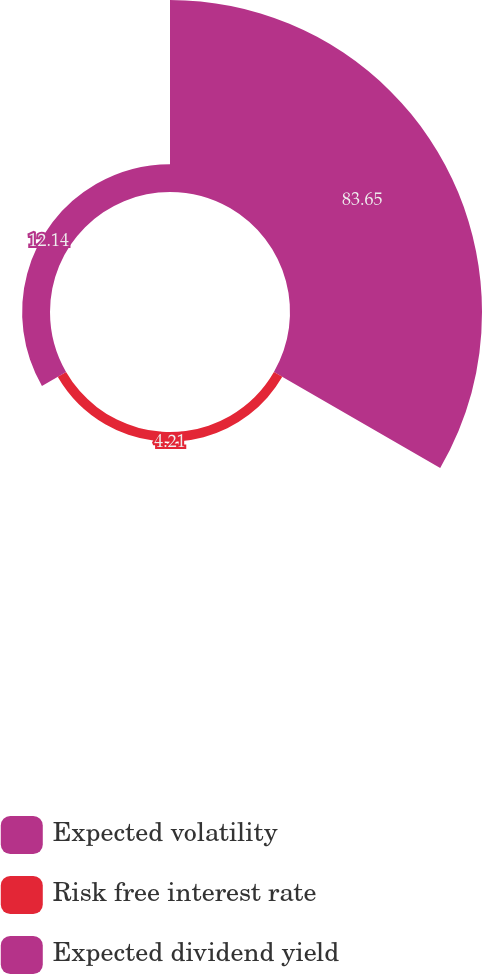Convert chart. <chart><loc_0><loc_0><loc_500><loc_500><pie_chart><fcel>Expected volatility<fcel>Risk free interest rate<fcel>Expected dividend yield<nl><fcel>83.65%<fcel>4.21%<fcel>12.14%<nl></chart> 